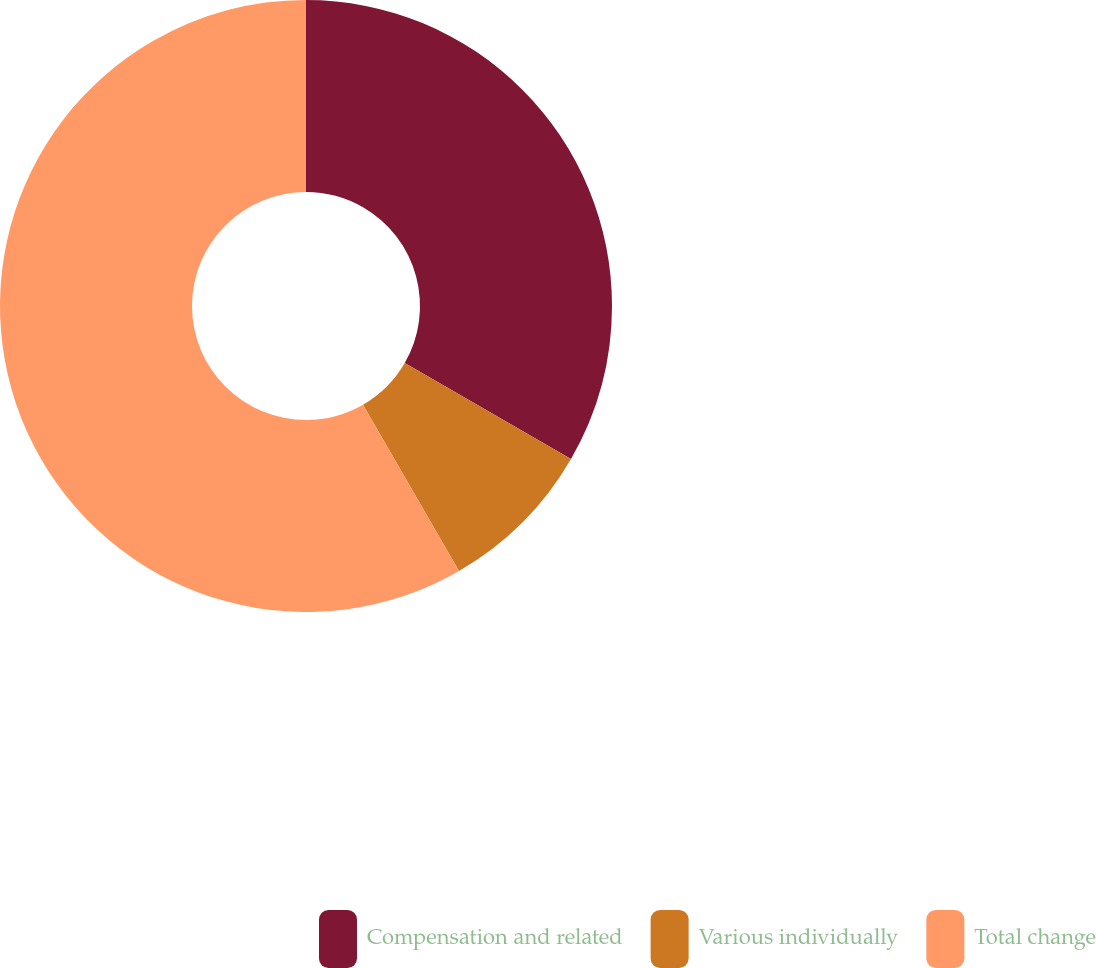Convert chart to OTSL. <chart><loc_0><loc_0><loc_500><loc_500><pie_chart><fcel>Compensation and related<fcel>Various individually<fcel>Total change<nl><fcel>33.33%<fcel>8.33%<fcel>58.33%<nl></chart> 